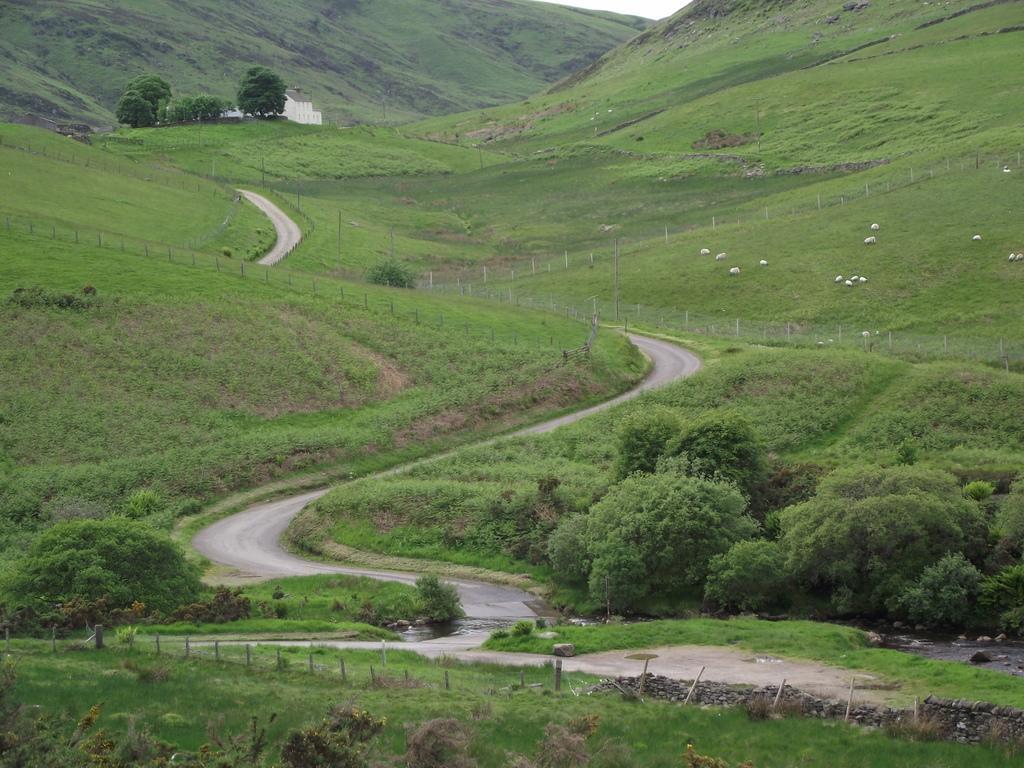How would you summarize this image in a sentence or two? In this image I can see the road, few poles on the ground, the grass, few trees and in the background I can see few animals which are white in color on the ground, the fencing, the road, few trees, a building, few mountains and the sky. 